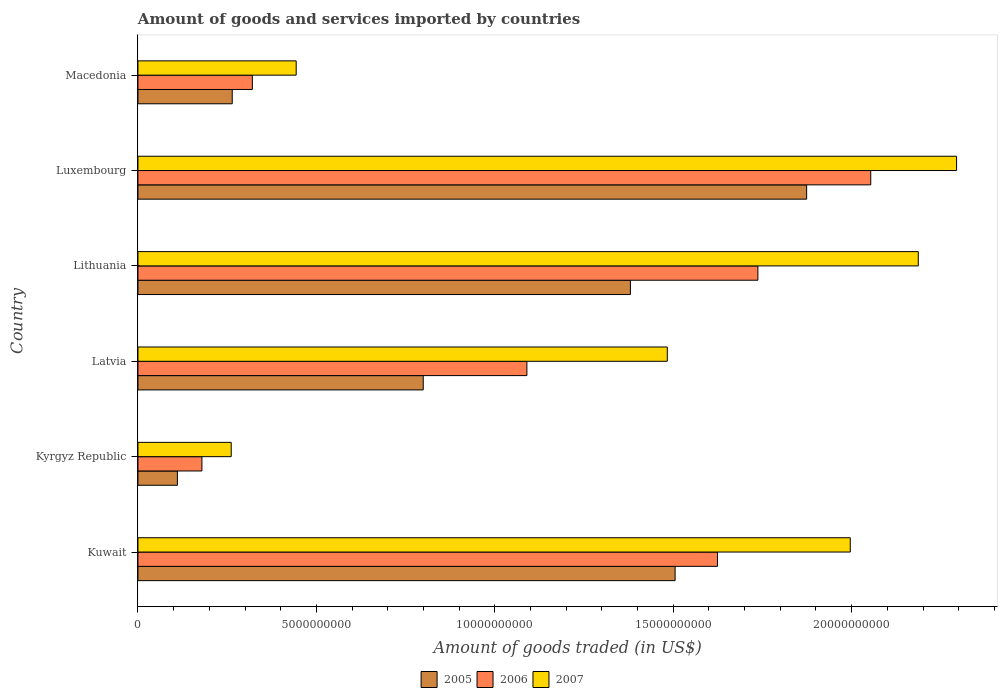How many different coloured bars are there?
Make the answer very short. 3. Are the number of bars per tick equal to the number of legend labels?
Your answer should be compact. Yes. What is the label of the 1st group of bars from the top?
Provide a short and direct response. Macedonia. In how many cases, is the number of bars for a given country not equal to the number of legend labels?
Your response must be concise. 0. What is the total amount of goods and services imported in 2006 in Lithuania?
Offer a terse response. 1.74e+1. Across all countries, what is the maximum total amount of goods and services imported in 2006?
Keep it short and to the point. 2.05e+1. Across all countries, what is the minimum total amount of goods and services imported in 2006?
Provide a short and direct response. 1.79e+09. In which country was the total amount of goods and services imported in 2007 maximum?
Offer a very short reply. Luxembourg. In which country was the total amount of goods and services imported in 2007 minimum?
Your answer should be very brief. Kyrgyz Republic. What is the total total amount of goods and services imported in 2005 in the graph?
Your answer should be compact. 5.93e+1. What is the difference between the total amount of goods and services imported in 2005 in Kyrgyz Republic and that in Macedonia?
Offer a terse response. -1.54e+09. What is the difference between the total amount of goods and services imported in 2005 in Kuwait and the total amount of goods and services imported in 2007 in Macedonia?
Keep it short and to the point. 1.06e+1. What is the average total amount of goods and services imported in 2005 per country?
Your answer should be compact. 9.89e+09. What is the difference between the total amount of goods and services imported in 2007 and total amount of goods and services imported in 2006 in Macedonia?
Your answer should be very brief. 1.23e+09. In how many countries, is the total amount of goods and services imported in 2006 greater than 22000000000 US$?
Give a very brief answer. 0. What is the ratio of the total amount of goods and services imported in 2007 in Luxembourg to that in Macedonia?
Offer a very short reply. 5.17. Is the total amount of goods and services imported in 2006 in Lithuania less than that in Macedonia?
Keep it short and to the point. No. Is the difference between the total amount of goods and services imported in 2007 in Kuwait and Lithuania greater than the difference between the total amount of goods and services imported in 2006 in Kuwait and Lithuania?
Give a very brief answer. No. What is the difference between the highest and the second highest total amount of goods and services imported in 2005?
Provide a succinct answer. 3.69e+09. What is the difference between the highest and the lowest total amount of goods and services imported in 2006?
Make the answer very short. 1.87e+1. In how many countries, is the total amount of goods and services imported in 2005 greater than the average total amount of goods and services imported in 2005 taken over all countries?
Your answer should be very brief. 3. Is the sum of the total amount of goods and services imported in 2006 in Kuwait and Latvia greater than the maximum total amount of goods and services imported in 2005 across all countries?
Ensure brevity in your answer.  Yes. What does the 3rd bar from the top in Luxembourg represents?
Your answer should be compact. 2005. What does the 1st bar from the bottom in Macedonia represents?
Your answer should be compact. 2005. Are all the bars in the graph horizontal?
Your answer should be compact. Yes. Where does the legend appear in the graph?
Offer a terse response. Bottom center. What is the title of the graph?
Your response must be concise. Amount of goods and services imported by countries. What is the label or title of the X-axis?
Offer a very short reply. Amount of goods traded (in US$). What is the Amount of goods traded (in US$) of 2005 in Kuwait?
Provide a short and direct response. 1.51e+1. What is the Amount of goods traded (in US$) of 2006 in Kuwait?
Your answer should be compact. 1.62e+1. What is the Amount of goods traded (in US$) of 2007 in Kuwait?
Offer a very short reply. 2.00e+1. What is the Amount of goods traded (in US$) in 2005 in Kyrgyz Republic?
Your answer should be compact. 1.11e+09. What is the Amount of goods traded (in US$) of 2006 in Kyrgyz Republic?
Provide a succinct answer. 1.79e+09. What is the Amount of goods traded (in US$) in 2007 in Kyrgyz Republic?
Offer a terse response. 2.61e+09. What is the Amount of goods traded (in US$) of 2005 in Latvia?
Offer a terse response. 7.99e+09. What is the Amount of goods traded (in US$) in 2006 in Latvia?
Provide a succinct answer. 1.09e+1. What is the Amount of goods traded (in US$) of 2007 in Latvia?
Offer a terse response. 1.48e+1. What is the Amount of goods traded (in US$) of 2005 in Lithuania?
Your answer should be compact. 1.38e+1. What is the Amount of goods traded (in US$) of 2006 in Lithuania?
Keep it short and to the point. 1.74e+1. What is the Amount of goods traded (in US$) in 2007 in Lithuania?
Give a very brief answer. 2.19e+1. What is the Amount of goods traded (in US$) in 2005 in Luxembourg?
Your response must be concise. 1.87e+1. What is the Amount of goods traded (in US$) of 2006 in Luxembourg?
Offer a very short reply. 2.05e+1. What is the Amount of goods traded (in US$) of 2007 in Luxembourg?
Offer a terse response. 2.29e+1. What is the Amount of goods traded (in US$) in 2005 in Macedonia?
Provide a short and direct response. 2.64e+09. What is the Amount of goods traded (in US$) in 2006 in Macedonia?
Ensure brevity in your answer.  3.21e+09. What is the Amount of goods traded (in US$) in 2007 in Macedonia?
Your response must be concise. 4.43e+09. Across all countries, what is the maximum Amount of goods traded (in US$) of 2005?
Offer a very short reply. 1.87e+1. Across all countries, what is the maximum Amount of goods traded (in US$) of 2006?
Your response must be concise. 2.05e+1. Across all countries, what is the maximum Amount of goods traded (in US$) in 2007?
Offer a very short reply. 2.29e+1. Across all countries, what is the minimum Amount of goods traded (in US$) of 2005?
Make the answer very short. 1.11e+09. Across all countries, what is the minimum Amount of goods traded (in US$) of 2006?
Keep it short and to the point. 1.79e+09. Across all countries, what is the minimum Amount of goods traded (in US$) in 2007?
Make the answer very short. 2.61e+09. What is the total Amount of goods traded (in US$) in 2005 in the graph?
Your answer should be compact. 5.93e+1. What is the total Amount of goods traded (in US$) of 2006 in the graph?
Your answer should be very brief. 7.00e+1. What is the total Amount of goods traded (in US$) in 2007 in the graph?
Make the answer very short. 8.67e+1. What is the difference between the Amount of goods traded (in US$) of 2005 in Kuwait and that in Kyrgyz Republic?
Ensure brevity in your answer.  1.39e+1. What is the difference between the Amount of goods traded (in US$) in 2006 in Kuwait and that in Kyrgyz Republic?
Ensure brevity in your answer.  1.44e+1. What is the difference between the Amount of goods traded (in US$) in 2007 in Kuwait and that in Kyrgyz Republic?
Offer a very short reply. 1.73e+1. What is the difference between the Amount of goods traded (in US$) in 2005 in Kuwait and that in Latvia?
Offer a terse response. 7.06e+09. What is the difference between the Amount of goods traded (in US$) of 2006 in Kuwait and that in Latvia?
Provide a short and direct response. 5.34e+09. What is the difference between the Amount of goods traded (in US$) in 2007 in Kuwait and that in Latvia?
Offer a very short reply. 5.13e+09. What is the difference between the Amount of goods traded (in US$) in 2005 in Kuwait and that in Lithuania?
Provide a short and direct response. 1.25e+09. What is the difference between the Amount of goods traded (in US$) in 2006 in Kuwait and that in Lithuania?
Offer a terse response. -1.13e+09. What is the difference between the Amount of goods traded (in US$) of 2007 in Kuwait and that in Lithuania?
Your answer should be very brief. -1.91e+09. What is the difference between the Amount of goods traded (in US$) in 2005 in Kuwait and that in Luxembourg?
Give a very brief answer. -3.69e+09. What is the difference between the Amount of goods traded (in US$) in 2006 in Kuwait and that in Luxembourg?
Your answer should be compact. -4.30e+09. What is the difference between the Amount of goods traded (in US$) of 2007 in Kuwait and that in Luxembourg?
Your answer should be compact. -2.98e+09. What is the difference between the Amount of goods traded (in US$) in 2005 in Kuwait and that in Macedonia?
Keep it short and to the point. 1.24e+1. What is the difference between the Amount of goods traded (in US$) in 2006 in Kuwait and that in Macedonia?
Make the answer very short. 1.30e+1. What is the difference between the Amount of goods traded (in US$) in 2007 in Kuwait and that in Macedonia?
Offer a terse response. 1.55e+1. What is the difference between the Amount of goods traded (in US$) of 2005 in Kyrgyz Republic and that in Latvia?
Offer a very short reply. -6.89e+09. What is the difference between the Amount of goods traded (in US$) in 2006 in Kyrgyz Republic and that in Latvia?
Make the answer very short. -9.11e+09. What is the difference between the Amount of goods traded (in US$) in 2007 in Kyrgyz Republic and that in Latvia?
Ensure brevity in your answer.  -1.22e+1. What is the difference between the Amount of goods traded (in US$) of 2005 in Kyrgyz Republic and that in Lithuania?
Give a very brief answer. -1.27e+1. What is the difference between the Amount of goods traded (in US$) in 2006 in Kyrgyz Republic and that in Lithuania?
Your answer should be compact. -1.56e+1. What is the difference between the Amount of goods traded (in US$) in 2007 in Kyrgyz Republic and that in Lithuania?
Offer a terse response. -1.93e+1. What is the difference between the Amount of goods traded (in US$) in 2005 in Kyrgyz Republic and that in Luxembourg?
Make the answer very short. -1.76e+1. What is the difference between the Amount of goods traded (in US$) in 2006 in Kyrgyz Republic and that in Luxembourg?
Keep it short and to the point. -1.87e+1. What is the difference between the Amount of goods traded (in US$) in 2007 in Kyrgyz Republic and that in Luxembourg?
Make the answer very short. -2.03e+1. What is the difference between the Amount of goods traded (in US$) in 2005 in Kyrgyz Republic and that in Macedonia?
Make the answer very short. -1.54e+09. What is the difference between the Amount of goods traded (in US$) in 2006 in Kyrgyz Republic and that in Macedonia?
Keep it short and to the point. -1.41e+09. What is the difference between the Amount of goods traded (in US$) of 2007 in Kyrgyz Republic and that in Macedonia?
Keep it short and to the point. -1.82e+09. What is the difference between the Amount of goods traded (in US$) of 2005 in Latvia and that in Lithuania?
Your answer should be compact. -5.81e+09. What is the difference between the Amount of goods traded (in US$) of 2006 in Latvia and that in Lithuania?
Provide a short and direct response. -6.47e+09. What is the difference between the Amount of goods traded (in US$) of 2007 in Latvia and that in Lithuania?
Provide a short and direct response. -7.03e+09. What is the difference between the Amount of goods traded (in US$) of 2005 in Latvia and that in Luxembourg?
Make the answer very short. -1.07e+1. What is the difference between the Amount of goods traded (in US$) in 2006 in Latvia and that in Luxembourg?
Your response must be concise. -9.64e+09. What is the difference between the Amount of goods traded (in US$) in 2007 in Latvia and that in Luxembourg?
Provide a short and direct response. -8.11e+09. What is the difference between the Amount of goods traded (in US$) in 2005 in Latvia and that in Macedonia?
Provide a short and direct response. 5.35e+09. What is the difference between the Amount of goods traded (in US$) in 2006 in Latvia and that in Macedonia?
Keep it short and to the point. 7.69e+09. What is the difference between the Amount of goods traded (in US$) of 2007 in Latvia and that in Macedonia?
Your answer should be compact. 1.04e+1. What is the difference between the Amount of goods traded (in US$) in 2005 in Lithuania and that in Luxembourg?
Keep it short and to the point. -4.94e+09. What is the difference between the Amount of goods traded (in US$) of 2006 in Lithuania and that in Luxembourg?
Make the answer very short. -3.16e+09. What is the difference between the Amount of goods traded (in US$) in 2007 in Lithuania and that in Luxembourg?
Make the answer very short. -1.07e+09. What is the difference between the Amount of goods traded (in US$) in 2005 in Lithuania and that in Macedonia?
Make the answer very short. 1.12e+1. What is the difference between the Amount of goods traded (in US$) of 2006 in Lithuania and that in Macedonia?
Your answer should be compact. 1.42e+1. What is the difference between the Amount of goods traded (in US$) of 2007 in Lithuania and that in Macedonia?
Provide a succinct answer. 1.74e+1. What is the difference between the Amount of goods traded (in US$) of 2005 in Luxembourg and that in Macedonia?
Provide a succinct answer. 1.61e+1. What is the difference between the Amount of goods traded (in US$) in 2006 in Luxembourg and that in Macedonia?
Offer a very short reply. 1.73e+1. What is the difference between the Amount of goods traded (in US$) in 2007 in Luxembourg and that in Macedonia?
Provide a short and direct response. 1.85e+1. What is the difference between the Amount of goods traded (in US$) in 2005 in Kuwait and the Amount of goods traded (in US$) in 2006 in Kyrgyz Republic?
Offer a very short reply. 1.33e+1. What is the difference between the Amount of goods traded (in US$) of 2005 in Kuwait and the Amount of goods traded (in US$) of 2007 in Kyrgyz Republic?
Provide a short and direct response. 1.24e+1. What is the difference between the Amount of goods traded (in US$) in 2006 in Kuwait and the Amount of goods traded (in US$) in 2007 in Kyrgyz Republic?
Keep it short and to the point. 1.36e+1. What is the difference between the Amount of goods traded (in US$) of 2005 in Kuwait and the Amount of goods traded (in US$) of 2006 in Latvia?
Your response must be concise. 4.15e+09. What is the difference between the Amount of goods traded (in US$) in 2005 in Kuwait and the Amount of goods traded (in US$) in 2007 in Latvia?
Make the answer very short. 2.19e+08. What is the difference between the Amount of goods traded (in US$) of 2006 in Kuwait and the Amount of goods traded (in US$) of 2007 in Latvia?
Your answer should be compact. 1.41e+09. What is the difference between the Amount of goods traded (in US$) of 2005 in Kuwait and the Amount of goods traded (in US$) of 2006 in Lithuania?
Give a very brief answer. -2.32e+09. What is the difference between the Amount of goods traded (in US$) in 2005 in Kuwait and the Amount of goods traded (in US$) in 2007 in Lithuania?
Your response must be concise. -6.81e+09. What is the difference between the Amount of goods traded (in US$) of 2006 in Kuwait and the Amount of goods traded (in US$) of 2007 in Lithuania?
Offer a terse response. -5.63e+09. What is the difference between the Amount of goods traded (in US$) of 2005 in Kuwait and the Amount of goods traded (in US$) of 2006 in Luxembourg?
Ensure brevity in your answer.  -5.48e+09. What is the difference between the Amount of goods traded (in US$) in 2005 in Kuwait and the Amount of goods traded (in US$) in 2007 in Luxembourg?
Ensure brevity in your answer.  -7.89e+09. What is the difference between the Amount of goods traded (in US$) of 2006 in Kuwait and the Amount of goods traded (in US$) of 2007 in Luxembourg?
Your response must be concise. -6.70e+09. What is the difference between the Amount of goods traded (in US$) of 2005 in Kuwait and the Amount of goods traded (in US$) of 2006 in Macedonia?
Your answer should be compact. 1.18e+1. What is the difference between the Amount of goods traded (in US$) of 2005 in Kuwait and the Amount of goods traded (in US$) of 2007 in Macedonia?
Offer a very short reply. 1.06e+1. What is the difference between the Amount of goods traded (in US$) of 2006 in Kuwait and the Amount of goods traded (in US$) of 2007 in Macedonia?
Your answer should be very brief. 1.18e+1. What is the difference between the Amount of goods traded (in US$) in 2005 in Kyrgyz Republic and the Amount of goods traded (in US$) in 2006 in Latvia?
Give a very brief answer. -9.79e+09. What is the difference between the Amount of goods traded (in US$) in 2005 in Kyrgyz Republic and the Amount of goods traded (in US$) in 2007 in Latvia?
Your response must be concise. -1.37e+1. What is the difference between the Amount of goods traded (in US$) in 2006 in Kyrgyz Republic and the Amount of goods traded (in US$) in 2007 in Latvia?
Your answer should be very brief. -1.30e+1. What is the difference between the Amount of goods traded (in US$) of 2005 in Kyrgyz Republic and the Amount of goods traded (in US$) of 2006 in Lithuania?
Your answer should be compact. -1.63e+1. What is the difference between the Amount of goods traded (in US$) of 2005 in Kyrgyz Republic and the Amount of goods traded (in US$) of 2007 in Lithuania?
Your response must be concise. -2.08e+1. What is the difference between the Amount of goods traded (in US$) of 2006 in Kyrgyz Republic and the Amount of goods traded (in US$) of 2007 in Lithuania?
Give a very brief answer. -2.01e+1. What is the difference between the Amount of goods traded (in US$) of 2005 in Kyrgyz Republic and the Amount of goods traded (in US$) of 2006 in Luxembourg?
Offer a very short reply. -1.94e+1. What is the difference between the Amount of goods traded (in US$) in 2005 in Kyrgyz Republic and the Amount of goods traded (in US$) in 2007 in Luxembourg?
Provide a short and direct response. -2.18e+1. What is the difference between the Amount of goods traded (in US$) in 2006 in Kyrgyz Republic and the Amount of goods traded (in US$) in 2007 in Luxembourg?
Make the answer very short. -2.11e+1. What is the difference between the Amount of goods traded (in US$) in 2005 in Kyrgyz Republic and the Amount of goods traded (in US$) in 2006 in Macedonia?
Make the answer very short. -2.10e+09. What is the difference between the Amount of goods traded (in US$) of 2005 in Kyrgyz Republic and the Amount of goods traded (in US$) of 2007 in Macedonia?
Offer a very short reply. -3.33e+09. What is the difference between the Amount of goods traded (in US$) in 2006 in Kyrgyz Republic and the Amount of goods traded (in US$) in 2007 in Macedonia?
Ensure brevity in your answer.  -2.64e+09. What is the difference between the Amount of goods traded (in US$) of 2005 in Latvia and the Amount of goods traded (in US$) of 2006 in Lithuania?
Your response must be concise. -9.38e+09. What is the difference between the Amount of goods traded (in US$) of 2005 in Latvia and the Amount of goods traded (in US$) of 2007 in Lithuania?
Make the answer very short. -1.39e+1. What is the difference between the Amount of goods traded (in US$) in 2006 in Latvia and the Amount of goods traded (in US$) in 2007 in Lithuania?
Offer a terse response. -1.10e+1. What is the difference between the Amount of goods traded (in US$) in 2005 in Latvia and the Amount of goods traded (in US$) in 2006 in Luxembourg?
Make the answer very short. -1.25e+1. What is the difference between the Amount of goods traded (in US$) of 2005 in Latvia and the Amount of goods traded (in US$) of 2007 in Luxembourg?
Give a very brief answer. -1.49e+1. What is the difference between the Amount of goods traded (in US$) in 2006 in Latvia and the Amount of goods traded (in US$) in 2007 in Luxembourg?
Offer a terse response. -1.20e+1. What is the difference between the Amount of goods traded (in US$) of 2005 in Latvia and the Amount of goods traded (in US$) of 2006 in Macedonia?
Provide a short and direct response. 4.79e+09. What is the difference between the Amount of goods traded (in US$) in 2005 in Latvia and the Amount of goods traded (in US$) in 2007 in Macedonia?
Your answer should be very brief. 3.56e+09. What is the difference between the Amount of goods traded (in US$) of 2006 in Latvia and the Amount of goods traded (in US$) of 2007 in Macedonia?
Make the answer very short. 6.47e+09. What is the difference between the Amount of goods traded (in US$) of 2005 in Lithuania and the Amount of goods traded (in US$) of 2006 in Luxembourg?
Make the answer very short. -6.74e+09. What is the difference between the Amount of goods traded (in US$) in 2005 in Lithuania and the Amount of goods traded (in US$) in 2007 in Luxembourg?
Your answer should be very brief. -9.14e+09. What is the difference between the Amount of goods traded (in US$) in 2006 in Lithuania and the Amount of goods traded (in US$) in 2007 in Luxembourg?
Offer a terse response. -5.57e+09. What is the difference between the Amount of goods traded (in US$) of 2005 in Lithuania and the Amount of goods traded (in US$) of 2006 in Macedonia?
Offer a very short reply. 1.06e+1. What is the difference between the Amount of goods traded (in US$) in 2005 in Lithuania and the Amount of goods traded (in US$) in 2007 in Macedonia?
Your answer should be compact. 9.37e+09. What is the difference between the Amount of goods traded (in US$) in 2006 in Lithuania and the Amount of goods traded (in US$) in 2007 in Macedonia?
Make the answer very short. 1.29e+1. What is the difference between the Amount of goods traded (in US$) in 2005 in Luxembourg and the Amount of goods traded (in US$) in 2006 in Macedonia?
Your response must be concise. 1.55e+1. What is the difference between the Amount of goods traded (in US$) of 2005 in Luxembourg and the Amount of goods traded (in US$) of 2007 in Macedonia?
Offer a very short reply. 1.43e+1. What is the difference between the Amount of goods traded (in US$) of 2006 in Luxembourg and the Amount of goods traded (in US$) of 2007 in Macedonia?
Give a very brief answer. 1.61e+1. What is the average Amount of goods traded (in US$) of 2005 per country?
Make the answer very short. 9.89e+09. What is the average Amount of goods traded (in US$) in 2006 per country?
Ensure brevity in your answer.  1.17e+1. What is the average Amount of goods traded (in US$) in 2007 per country?
Your answer should be very brief. 1.44e+1. What is the difference between the Amount of goods traded (in US$) of 2005 and Amount of goods traded (in US$) of 2006 in Kuwait?
Give a very brief answer. -1.19e+09. What is the difference between the Amount of goods traded (in US$) of 2005 and Amount of goods traded (in US$) of 2007 in Kuwait?
Your response must be concise. -4.91e+09. What is the difference between the Amount of goods traded (in US$) in 2006 and Amount of goods traded (in US$) in 2007 in Kuwait?
Offer a terse response. -3.72e+09. What is the difference between the Amount of goods traded (in US$) of 2005 and Amount of goods traded (in US$) of 2006 in Kyrgyz Republic?
Provide a succinct answer. -6.87e+08. What is the difference between the Amount of goods traded (in US$) of 2005 and Amount of goods traded (in US$) of 2007 in Kyrgyz Republic?
Your answer should be very brief. -1.51e+09. What is the difference between the Amount of goods traded (in US$) in 2006 and Amount of goods traded (in US$) in 2007 in Kyrgyz Republic?
Your answer should be compact. -8.21e+08. What is the difference between the Amount of goods traded (in US$) of 2005 and Amount of goods traded (in US$) of 2006 in Latvia?
Your response must be concise. -2.90e+09. What is the difference between the Amount of goods traded (in US$) in 2005 and Amount of goods traded (in US$) in 2007 in Latvia?
Provide a short and direct response. -6.84e+09. What is the difference between the Amount of goods traded (in US$) of 2006 and Amount of goods traded (in US$) of 2007 in Latvia?
Ensure brevity in your answer.  -3.93e+09. What is the difference between the Amount of goods traded (in US$) in 2005 and Amount of goods traded (in US$) in 2006 in Lithuania?
Your response must be concise. -3.57e+09. What is the difference between the Amount of goods traded (in US$) in 2005 and Amount of goods traded (in US$) in 2007 in Lithuania?
Provide a short and direct response. -8.07e+09. What is the difference between the Amount of goods traded (in US$) in 2006 and Amount of goods traded (in US$) in 2007 in Lithuania?
Offer a very short reply. -4.50e+09. What is the difference between the Amount of goods traded (in US$) in 2005 and Amount of goods traded (in US$) in 2006 in Luxembourg?
Make the answer very short. -1.80e+09. What is the difference between the Amount of goods traded (in US$) of 2005 and Amount of goods traded (in US$) of 2007 in Luxembourg?
Keep it short and to the point. -4.20e+09. What is the difference between the Amount of goods traded (in US$) of 2006 and Amount of goods traded (in US$) of 2007 in Luxembourg?
Provide a succinct answer. -2.40e+09. What is the difference between the Amount of goods traded (in US$) of 2005 and Amount of goods traded (in US$) of 2006 in Macedonia?
Provide a short and direct response. -5.64e+08. What is the difference between the Amount of goods traded (in US$) in 2005 and Amount of goods traded (in US$) in 2007 in Macedonia?
Give a very brief answer. -1.79e+09. What is the difference between the Amount of goods traded (in US$) in 2006 and Amount of goods traded (in US$) in 2007 in Macedonia?
Provide a short and direct response. -1.23e+09. What is the ratio of the Amount of goods traded (in US$) of 2005 in Kuwait to that in Kyrgyz Republic?
Keep it short and to the point. 13.62. What is the ratio of the Amount of goods traded (in US$) in 2006 in Kuwait to that in Kyrgyz Republic?
Your answer should be compact. 9.06. What is the ratio of the Amount of goods traded (in US$) in 2007 in Kuwait to that in Kyrgyz Republic?
Keep it short and to the point. 7.64. What is the ratio of the Amount of goods traded (in US$) of 2005 in Kuwait to that in Latvia?
Your answer should be compact. 1.88. What is the ratio of the Amount of goods traded (in US$) in 2006 in Kuwait to that in Latvia?
Your response must be concise. 1.49. What is the ratio of the Amount of goods traded (in US$) of 2007 in Kuwait to that in Latvia?
Ensure brevity in your answer.  1.35. What is the ratio of the Amount of goods traded (in US$) of 2005 in Kuwait to that in Lithuania?
Provide a short and direct response. 1.09. What is the ratio of the Amount of goods traded (in US$) in 2006 in Kuwait to that in Lithuania?
Your answer should be compact. 0.93. What is the ratio of the Amount of goods traded (in US$) in 2007 in Kuwait to that in Lithuania?
Keep it short and to the point. 0.91. What is the ratio of the Amount of goods traded (in US$) of 2005 in Kuwait to that in Luxembourg?
Provide a short and direct response. 0.8. What is the ratio of the Amount of goods traded (in US$) in 2006 in Kuwait to that in Luxembourg?
Keep it short and to the point. 0.79. What is the ratio of the Amount of goods traded (in US$) of 2007 in Kuwait to that in Luxembourg?
Keep it short and to the point. 0.87. What is the ratio of the Amount of goods traded (in US$) in 2005 in Kuwait to that in Macedonia?
Keep it short and to the point. 5.7. What is the ratio of the Amount of goods traded (in US$) of 2006 in Kuwait to that in Macedonia?
Keep it short and to the point. 5.07. What is the ratio of the Amount of goods traded (in US$) in 2007 in Kuwait to that in Macedonia?
Your answer should be very brief. 4.5. What is the ratio of the Amount of goods traded (in US$) of 2005 in Kyrgyz Republic to that in Latvia?
Your answer should be compact. 0.14. What is the ratio of the Amount of goods traded (in US$) in 2006 in Kyrgyz Republic to that in Latvia?
Provide a succinct answer. 0.16. What is the ratio of the Amount of goods traded (in US$) of 2007 in Kyrgyz Republic to that in Latvia?
Your answer should be very brief. 0.18. What is the ratio of the Amount of goods traded (in US$) in 2005 in Kyrgyz Republic to that in Lithuania?
Offer a very short reply. 0.08. What is the ratio of the Amount of goods traded (in US$) in 2006 in Kyrgyz Republic to that in Lithuania?
Offer a terse response. 0.1. What is the ratio of the Amount of goods traded (in US$) of 2007 in Kyrgyz Republic to that in Lithuania?
Provide a succinct answer. 0.12. What is the ratio of the Amount of goods traded (in US$) in 2005 in Kyrgyz Republic to that in Luxembourg?
Offer a terse response. 0.06. What is the ratio of the Amount of goods traded (in US$) in 2006 in Kyrgyz Republic to that in Luxembourg?
Your response must be concise. 0.09. What is the ratio of the Amount of goods traded (in US$) in 2007 in Kyrgyz Republic to that in Luxembourg?
Ensure brevity in your answer.  0.11. What is the ratio of the Amount of goods traded (in US$) of 2005 in Kyrgyz Republic to that in Macedonia?
Your answer should be very brief. 0.42. What is the ratio of the Amount of goods traded (in US$) in 2006 in Kyrgyz Republic to that in Macedonia?
Provide a succinct answer. 0.56. What is the ratio of the Amount of goods traded (in US$) in 2007 in Kyrgyz Republic to that in Macedonia?
Your response must be concise. 0.59. What is the ratio of the Amount of goods traded (in US$) in 2005 in Latvia to that in Lithuania?
Ensure brevity in your answer.  0.58. What is the ratio of the Amount of goods traded (in US$) of 2006 in Latvia to that in Lithuania?
Make the answer very short. 0.63. What is the ratio of the Amount of goods traded (in US$) in 2007 in Latvia to that in Lithuania?
Your answer should be very brief. 0.68. What is the ratio of the Amount of goods traded (in US$) of 2005 in Latvia to that in Luxembourg?
Provide a short and direct response. 0.43. What is the ratio of the Amount of goods traded (in US$) in 2006 in Latvia to that in Luxembourg?
Provide a succinct answer. 0.53. What is the ratio of the Amount of goods traded (in US$) of 2007 in Latvia to that in Luxembourg?
Ensure brevity in your answer.  0.65. What is the ratio of the Amount of goods traded (in US$) in 2005 in Latvia to that in Macedonia?
Give a very brief answer. 3.03. What is the ratio of the Amount of goods traded (in US$) of 2006 in Latvia to that in Macedonia?
Your answer should be compact. 3.4. What is the ratio of the Amount of goods traded (in US$) of 2007 in Latvia to that in Macedonia?
Offer a very short reply. 3.35. What is the ratio of the Amount of goods traded (in US$) in 2005 in Lithuania to that in Luxembourg?
Offer a very short reply. 0.74. What is the ratio of the Amount of goods traded (in US$) of 2006 in Lithuania to that in Luxembourg?
Offer a terse response. 0.85. What is the ratio of the Amount of goods traded (in US$) of 2007 in Lithuania to that in Luxembourg?
Keep it short and to the point. 0.95. What is the ratio of the Amount of goods traded (in US$) of 2005 in Lithuania to that in Macedonia?
Give a very brief answer. 5.22. What is the ratio of the Amount of goods traded (in US$) of 2006 in Lithuania to that in Macedonia?
Your response must be concise. 5.42. What is the ratio of the Amount of goods traded (in US$) in 2007 in Lithuania to that in Macedonia?
Provide a succinct answer. 4.93. What is the ratio of the Amount of goods traded (in US$) in 2005 in Luxembourg to that in Macedonia?
Your response must be concise. 7.09. What is the ratio of the Amount of goods traded (in US$) in 2006 in Luxembourg to that in Macedonia?
Make the answer very short. 6.41. What is the ratio of the Amount of goods traded (in US$) in 2007 in Luxembourg to that in Macedonia?
Offer a very short reply. 5.17. What is the difference between the highest and the second highest Amount of goods traded (in US$) in 2005?
Offer a terse response. 3.69e+09. What is the difference between the highest and the second highest Amount of goods traded (in US$) in 2006?
Provide a short and direct response. 3.16e+09. What is the difference between the highest and the second highest Amount of goods traded (in US$) of 2007?
Give a very brief answer. 1.07e+09. What is the difference between the highest and the lowest Amount of goods traded (in US$) in 2005?
Offer a terse response. 1.76e+1. What is the difference between the highest and the lowest Amount of goods traded (in US$) of 2006?
Your response must be concise. 1.87e+1. What is the difference between the highest and the lowest Amount of goods traded (in US$) of 2007?
Give a very brief answer. 2.03e+1. 